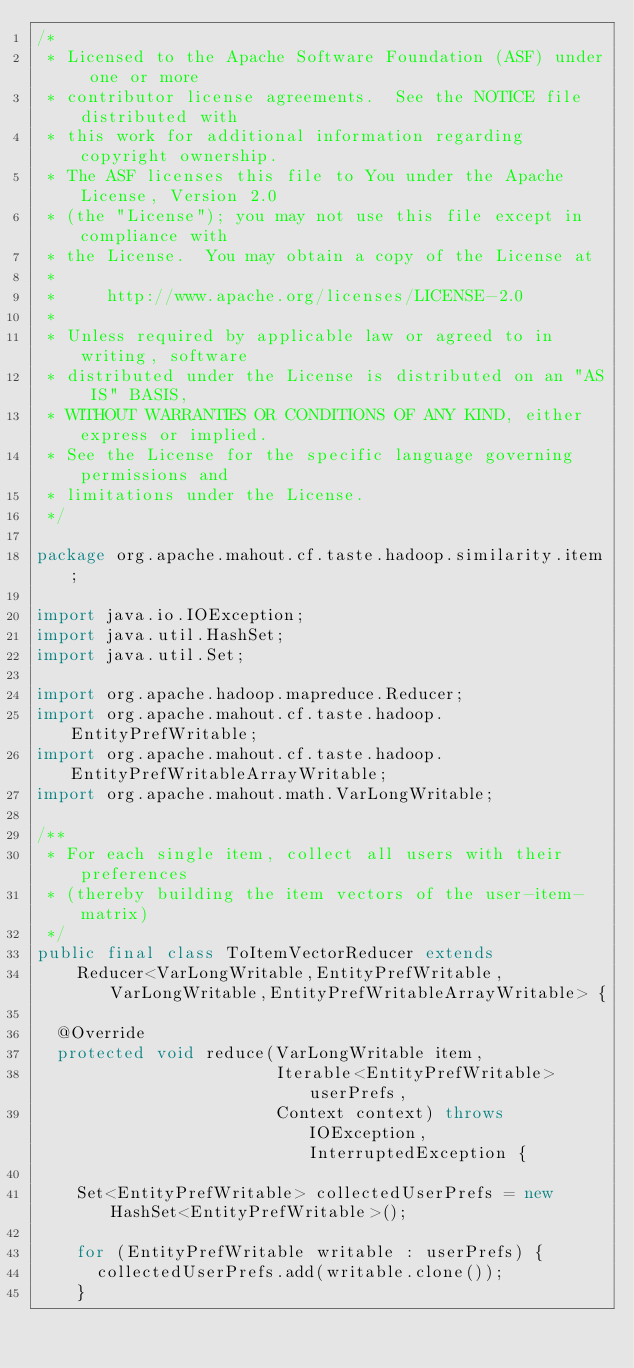Convert code to text. <code><loc_0><loc_0><loc_500><loc_500><_Java_>/*
 * Licensed to the Apache Software Foundation (ASF) under one or more
 * contributor license agreements.  See the NOTICE file distributed with
 * this work for additional information regarding copyright ownership.
 * The ASF licenses this file to You under the Apache License, Version 2.0
 * (the "License"); you may not use this file except in compliance with
 * the License.  You may obtain a copy of the License at
 *
 *     http://www.apache.org/licenses/LICENSE-2.0
 *
 * Unless required by applicable law or agreed to in writing, software
 * distributed under the License is distributed on an "AS IS" BASIS,
 * WITHOUT WARRANTIES OR CONDITIONS OF ANY KIND, either express or implied.
 * See the License for the specific language governing permissions and
 * limitations under the License.
 */

package org.apache.mahout.cf.taste.hadoop.similarity.item;

import java.io.IOException;
import java.util.HashSet;
import java.util.Set;

import org.apache.hadoop.mapreduce.Reducer;
import org.apache.mahout.cf.taste.hadoop.EntityPrefWritable;
import org.apache.mahout.cf.taste.hadoop.EntityPrefWritableArrayWritable;
import org.apache.mahout.math.VarLongWritable;

/**
 * For each single item, collect all users with their preferences
 * (thereby building the item vectors of the user-item-matrix)
 */
public final class ToItemVectorReducer extends
    Reducer<VarLongWritable,EntityPrefWritable,VarLongWritable,EntityPrefWritableArrayWritable> {

  @Override
  protected void reduce(VarLongWritable item,
                        Iterable<EntityPrefWritable> userPrefs,
                        Context context) throws IOException, InterruptedException {

    Set<EntityPrefWritable> collectedUserPrefs = new HashSet<EntityPrefWritable>();

    for (EntityPrefWritable writable : userPrefs) {
      collectedUserPrefs.add(writable.clone());
    }
</code> 